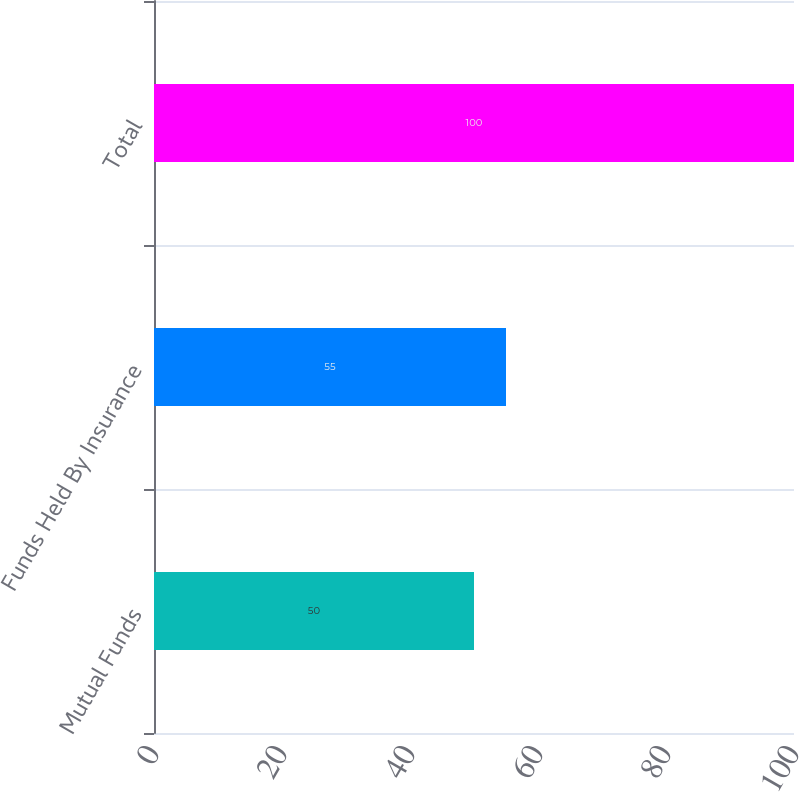Convert chart to OTSL. <chart><loc_0><loc_0><loc_500><loc_500><bar_chart><fcel>Mutual Funds<fcel>Funds Held By Insurance<fcel>Total<nl><fcel>50<fcel>55<fcel>100<nl></chart> 